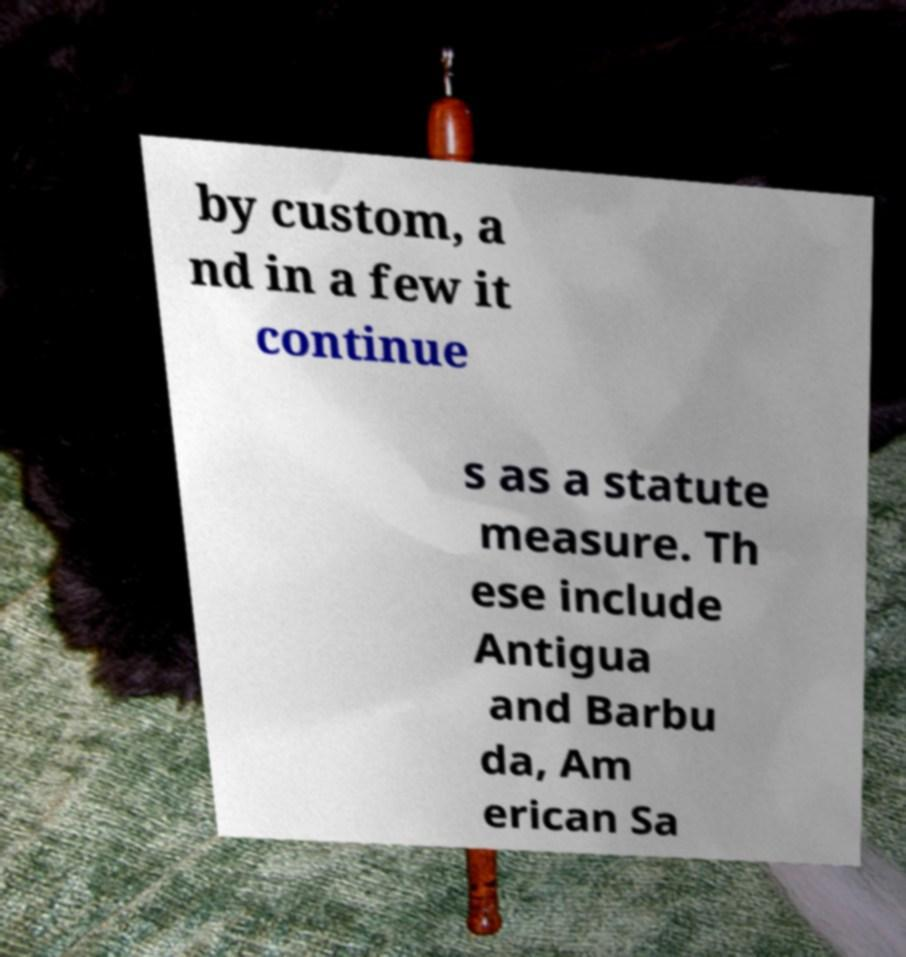Can you accurately transcribe the text from the provided image for me? by custom, a nd in a few it continue s as a statute measure. Th ese include Antigua and Barbu da, Am erican Sa 